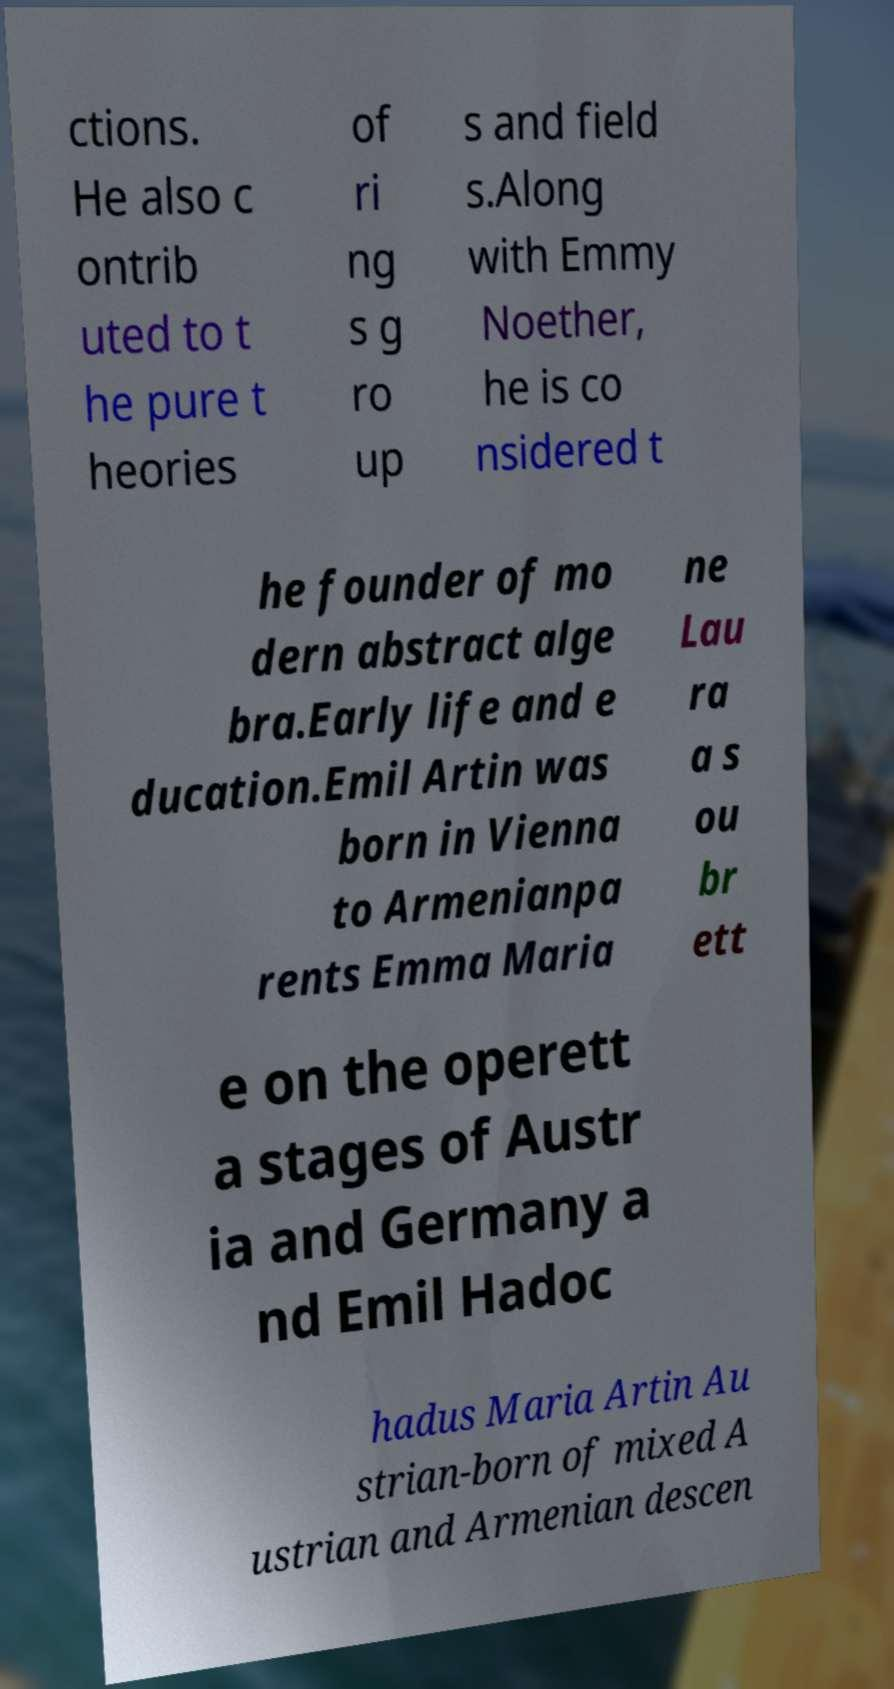Please read and relay the text visible in this image. What does it say? ctions. He also c ontrib uted to t he pure t heories of ri ng s g ro up s and field s.Along with Emmy Noether, he is co nsidered t he founder of mo dern abstract alge bra.Early life and e ducation.Emil Artin was born in Vienna to Armenianpa rents Emma Maria ne Lau ra a s ou br ett e on the operett a stages of Austr ia and Germany a nd Emil Hadoc hadus Maria Artin Au strian-born of mixed A ustrian and Armenian descen 